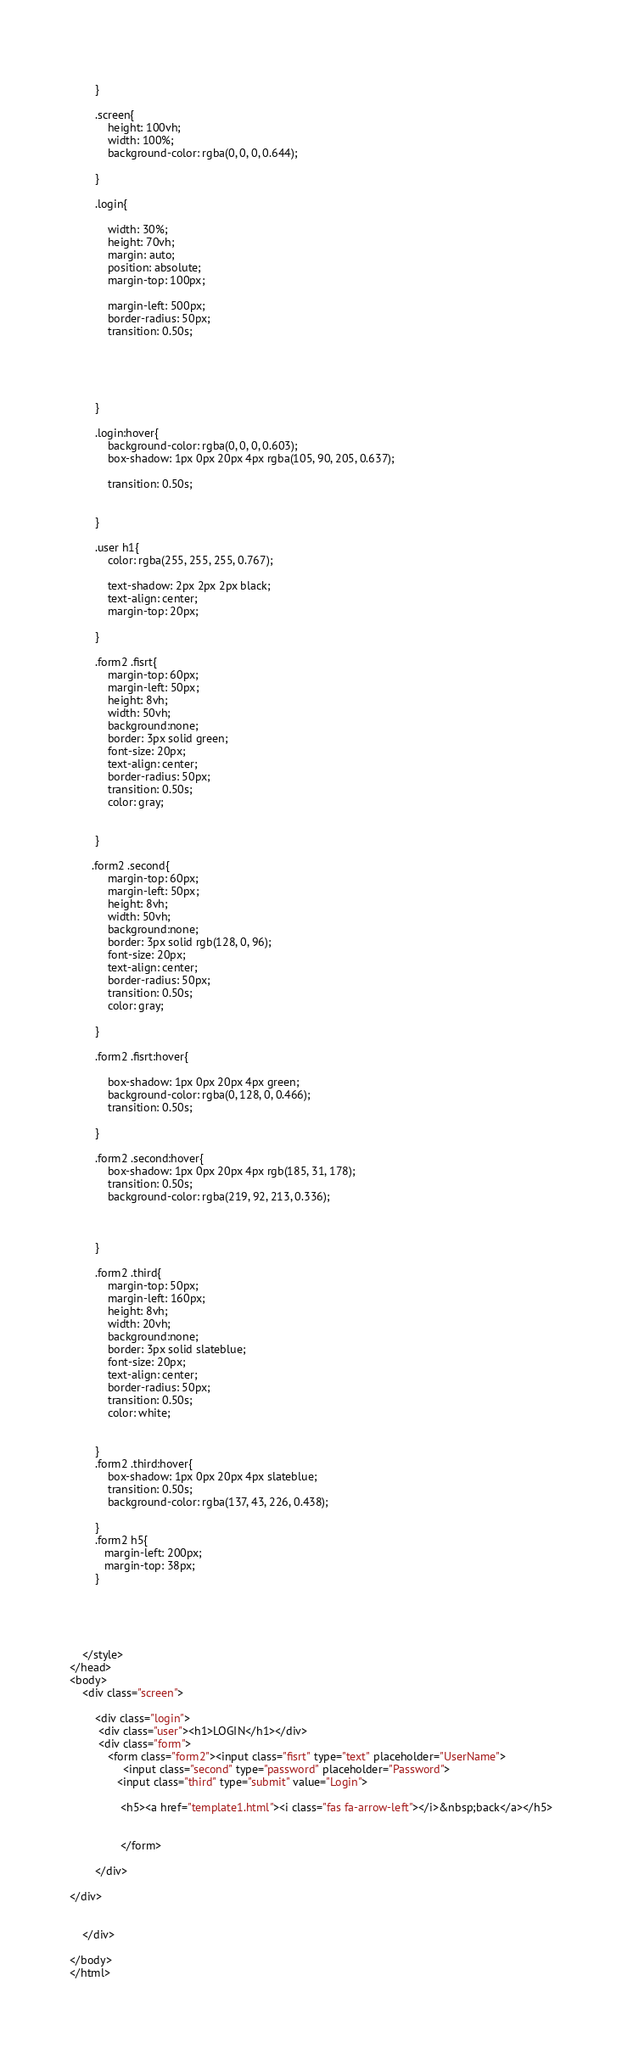Convert code to text. <code><loc_0><loc_0><loc_500><loc_500><_HTML_>          
        }

        .screen{
            height: 100vh;
            width: 100%;
            background-color: rgba(0, 0, 0, 0.644);
        
        }

        .login{
            
            width: 30%;
            height: 70vh;
            margin: auto;
            position: absolute;
            margin-top: 100px;
           
            margin-left: 500px;
            border-radius: 50px;
            transition: 0.50s;



            
         
        }

        .login:hover{
            background-color: rgba(0, 0, 0, 0.603);
            box-shadow: 1px 0px 20px 4px rgba(105, 90, 205, 0.637);
         
            transition: 0.50s;
            

        }

        .user h1{
            color: rgba(255, 255, 255, 0.767);
      
            text-shadow: 2px 2px 2px black;
            text-align: center;
            margin-top: 20px;
            
        }

        .form2 .fisrt{
            margin-top: 60px;
            margin-left: 50px;
            height: 8vh;
            width: 50vh;
            background:none;
            border: 3px solid green;
            font-size: 20px;
            text-align: center;
            border-radius: 50px;
            transition: 0.50s;
            color: gray;
            
         
        }

       .form2 .second{
            margin-top: 60px;
            margin-left: 50px;
            height: 8vh;
            width: 50vh;
            background:none;
            border: 3px solid rgb(128, 0, 96);
            font-size: 20px;
            text-align: center;
            border-radius: 50px;
            transition: 0.50s;
            color: gray;
         
        }

        .form2 .fisrt:hover{

            box-shadow: 1px 0px 20px 4px green;
            background-color: rgba(0, 128, 0, 0.466);
            transition: 0.50s;

        }

        .form2 .second:hover{
            box-shadow: 1px 0px 20px 4px rgb(185, 31, 178);
            transition: 0.50s;
            background-color: rgba(219, 92, 213, 0.336);



        }

        .form2 .third{
            margin-top: 50px;
            margin-left: 160px;
            height: 8vh;
            width: 20vh;
            background:none;
            border: 3px solid slateblue;
            font-size: 20px;
            text-align: center;
            border-radius: 50px;
            transition: 0.50s;
            color: white;
            
         
        }
        .form2 .third:hover{
            box-shadow: 1px 0px 20px 4px slateblue;
            transition: 0.50s;
            background-color: rgba(137, 43, 226, 0.438);
            
        }
        .form2 h5{
           margin-left: 200px;
           margin-top: 38px;
        }

    
        


    </style>
</head>
<body>
    <div class="screen">

        <div class="login">
         <div class="user"><h1>LOGIN</h1></div>
         <div class="form"> 
            <form class="form2"><input class="fisrt" type="text" placeholder="UserName">
                 <input class="second" type="password" placeholder="Password">
               <input class="third" type="submit" value="Login">

                <h5><a href="template1.html"><i class="fas fa-arrow-left"></i>&nbsp;back</a></h5>
               
                
                </form>

        </div>
       
</div>

 
    </div>
    
</body>
</html>
</code> 